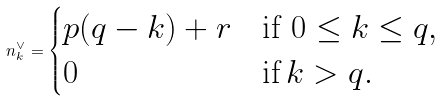Convert formula to latex. <formula><loc_0><loc_0><loc_500><loc_500>n _ { k } ^ { \vee } = \begin{cases} p ( q - k ) + r & \text {if $0 \leq k \leq q$} , \\ 0 & \text {if} \, k > q . \end{cases}</formula> 